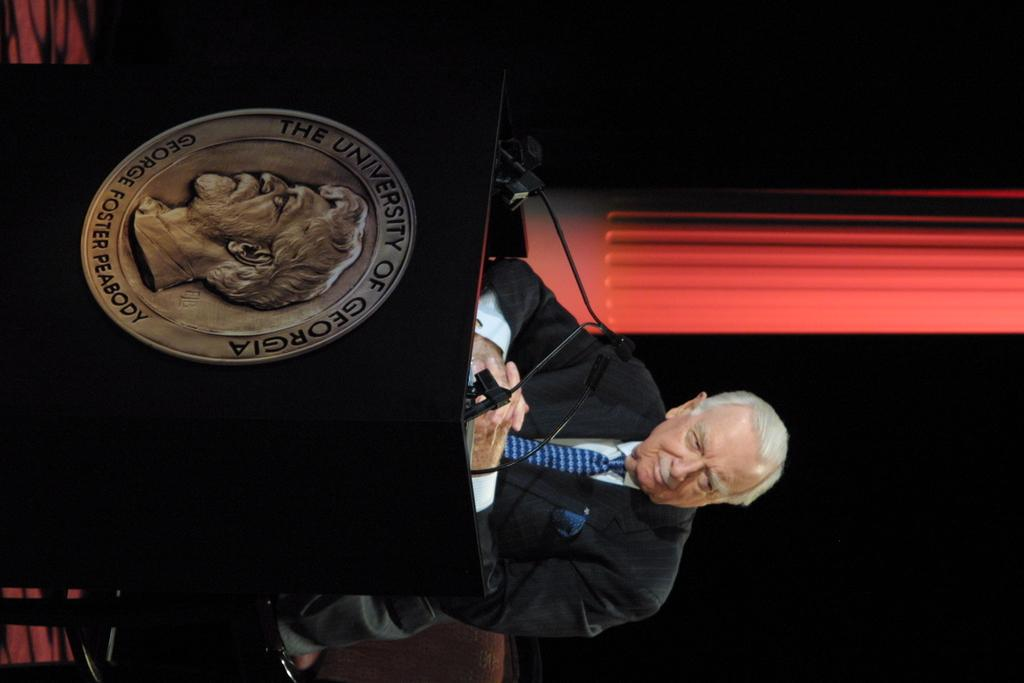<image>
Create a compact narrative representing the image presented. Man standing in front of a podium that has a coin from "The University of Georgia". 